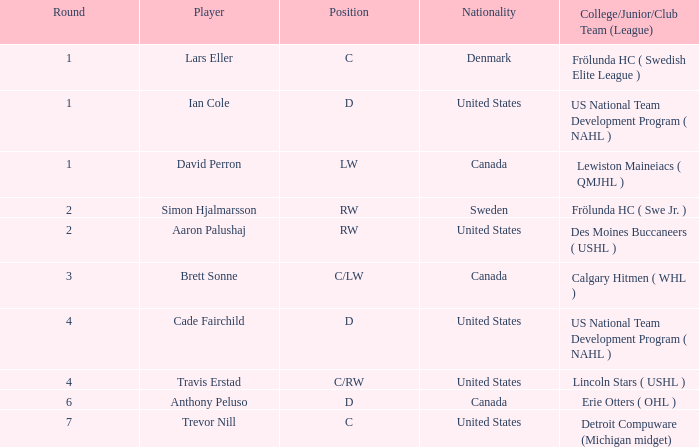What is the highest round of Ian Cole, who played position d from the United States? 1.0. 